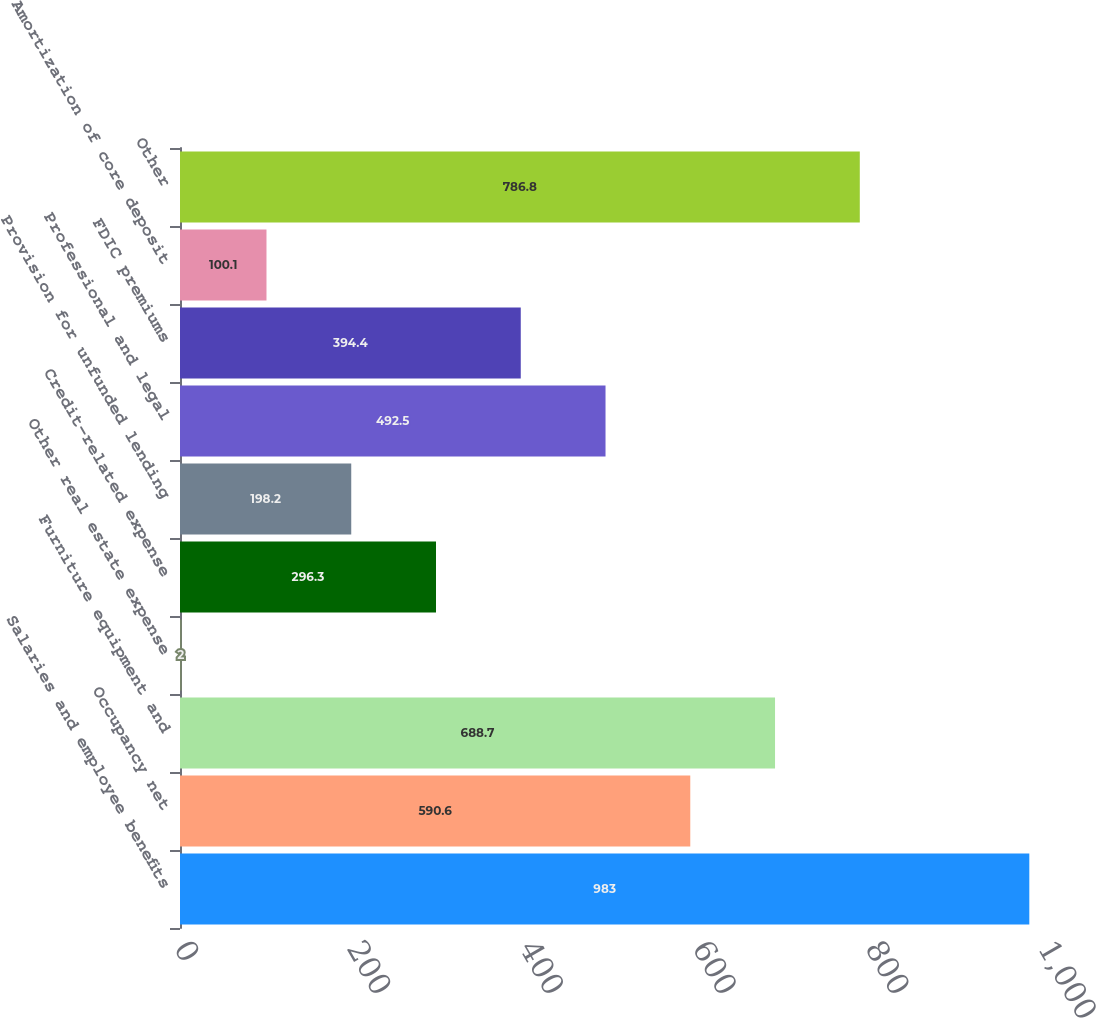<chart> <loc_0><loc_0><loc_500><loc_500><bar_chart><fcel>Salaries and employee benefits<fcel>Occupancy net<fcel>Furniture equipment and<fcel>Other real estate expense<fcel>Credit-related expense<fcel>Provision for unfunded lending<fcel>Professional and legal<fcel>FDIC premiums<fcel>Amortization of core deposit<fcel>Other<nl><fcel>983<fcel>590.6<fcel>688.7<fcel>2<fcel>296.3<fcel>198.2<fcel>492.5<fcel>394.4<fcel>100.1<fcel>786.8<nl></chart> 